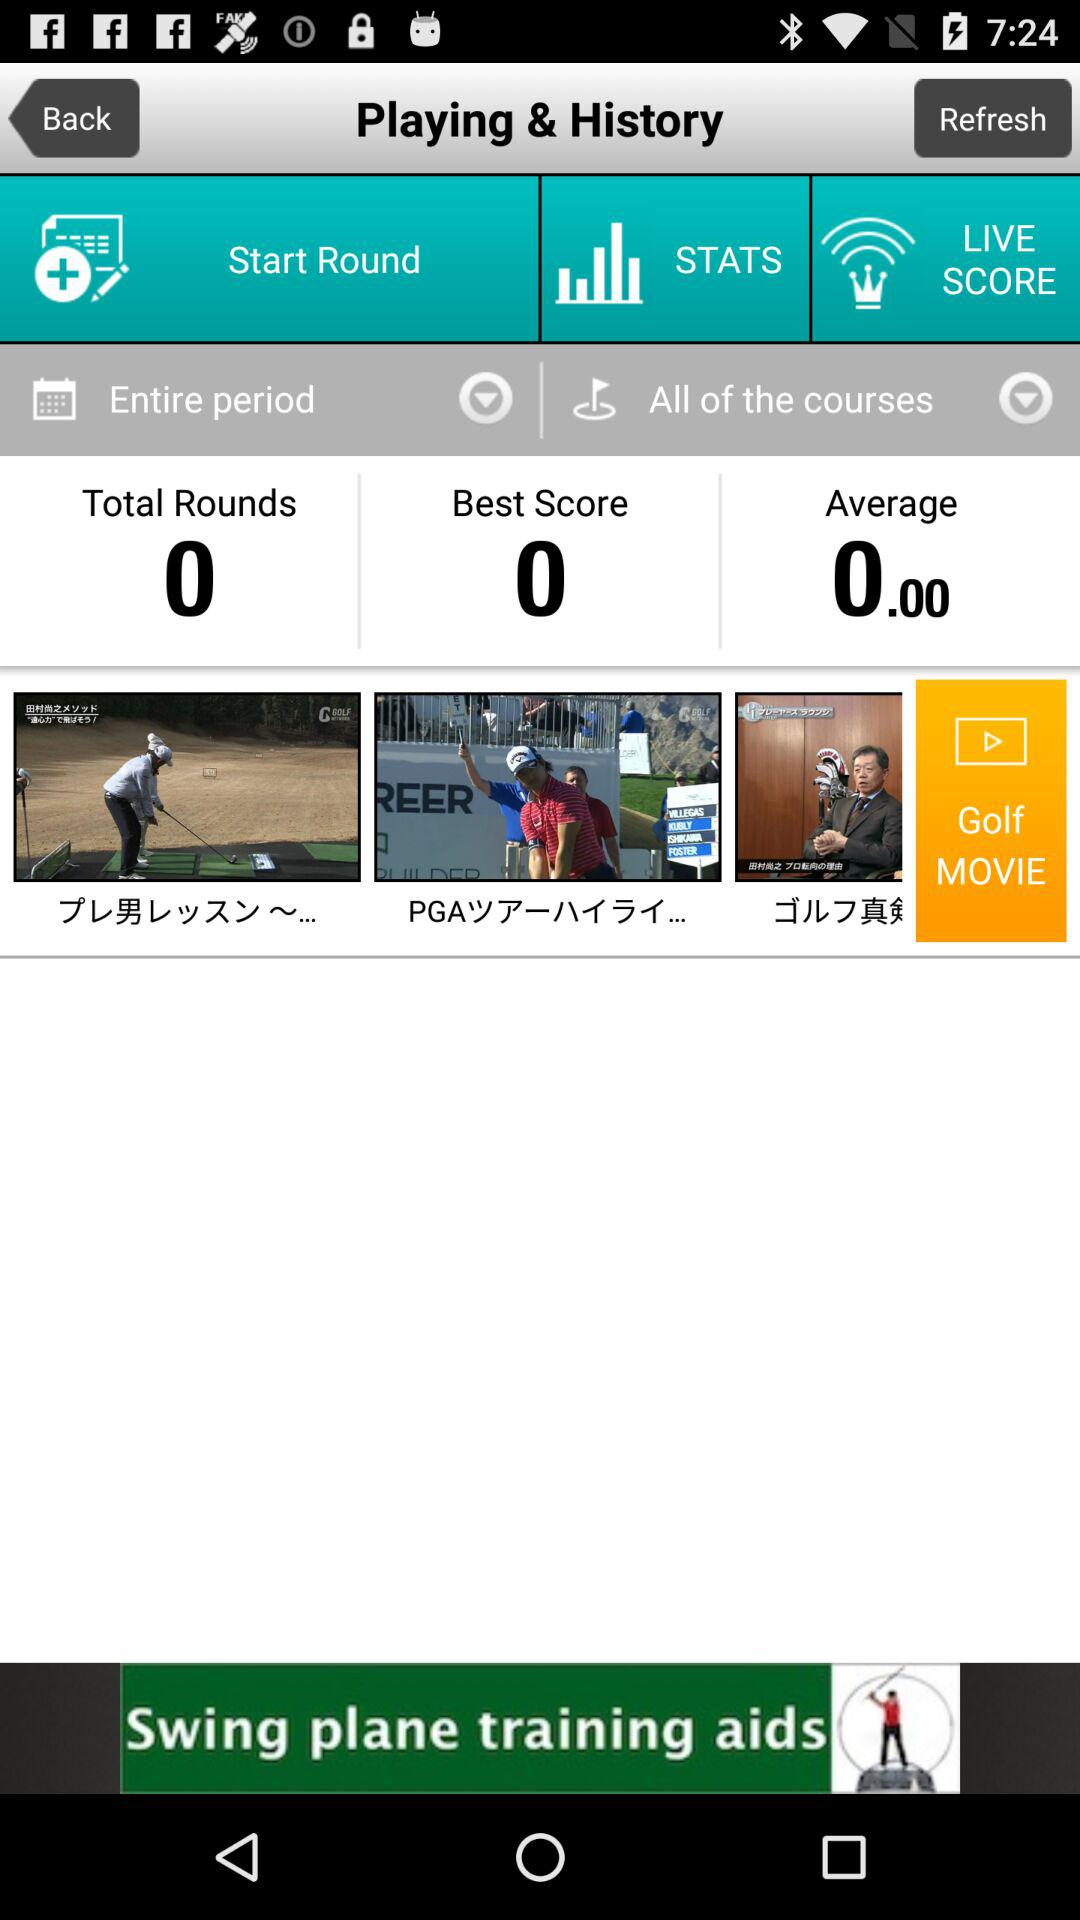What is the best score? The best score is 0. 